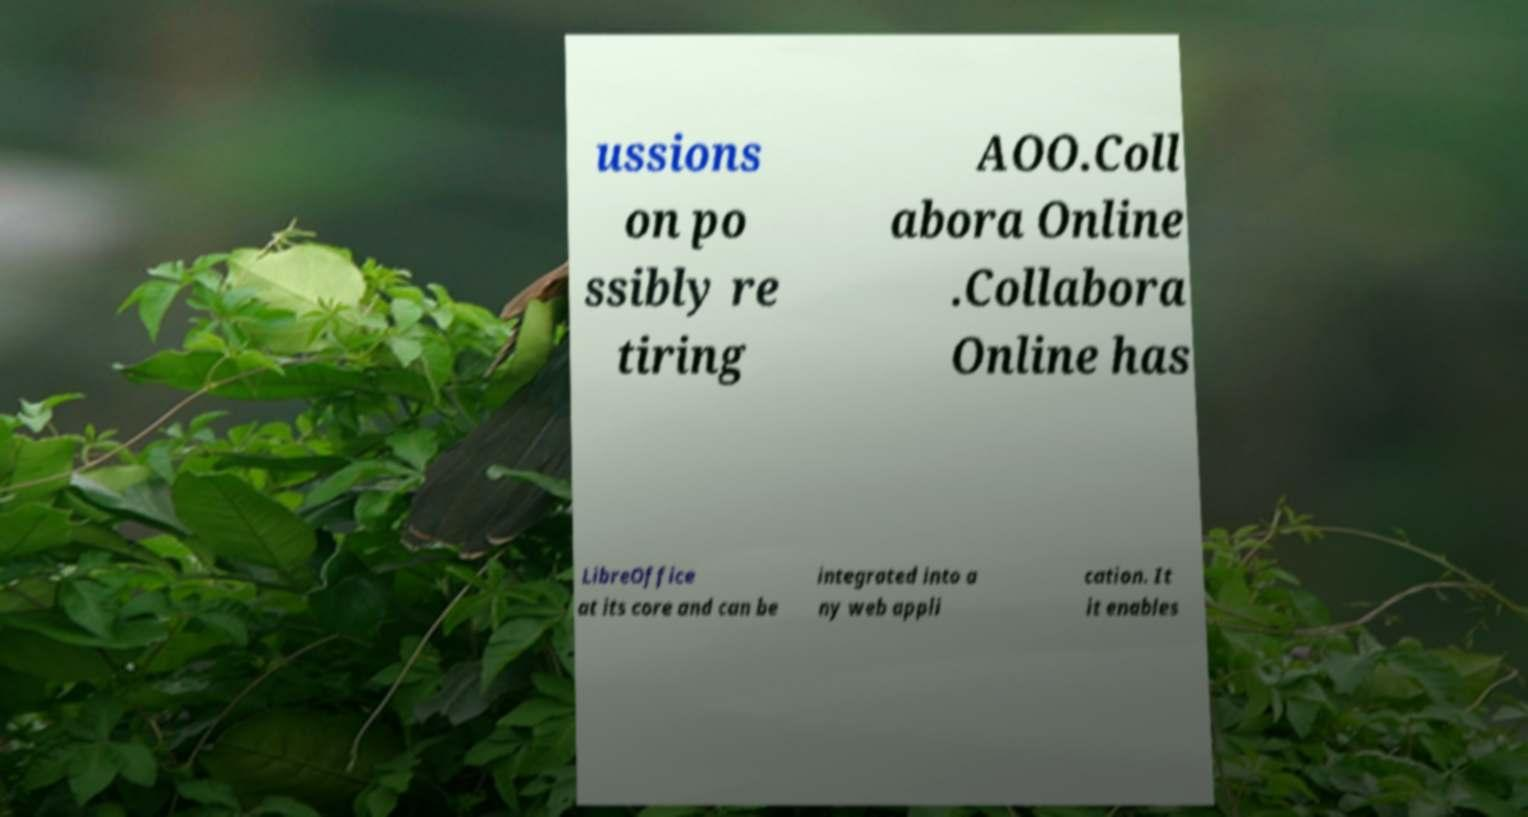Please identify and transcribe the text found in this image. ussions on po ssibly re tiring AOO.Coll abora Online .Collabora Online has LibreOffice at its core and can be integrated into a ny web appli cation. It it enables 